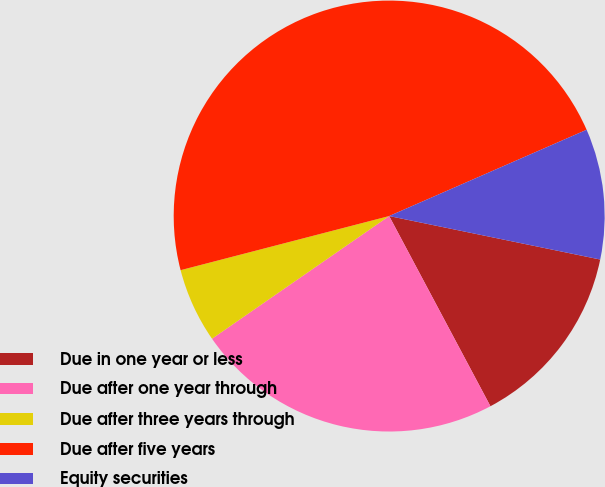<chart> <loc_0><loc_0><loc_500><loc_500><pie_chart><fcel>Due in one year or less<fcel>Due after one year through<fcel>Due after three years through<fcel>Due after five years<fcel>Equity securities<nl><fcel>13.98%<fcel>23.15%<fcel>5.6%<fcel>47.49%<fcel>9.79%<nl></chart> 